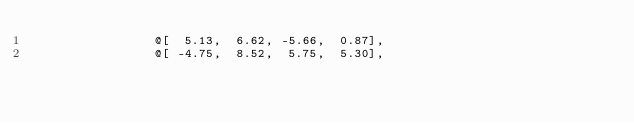<code> <loc_0><loc_0><loc_500><loc_500><_Nim_>                @[  5.13,  6.62, -5.66,  0.87],
                @[ -4.75,  8.52,  5.75,  5.30],</code> 